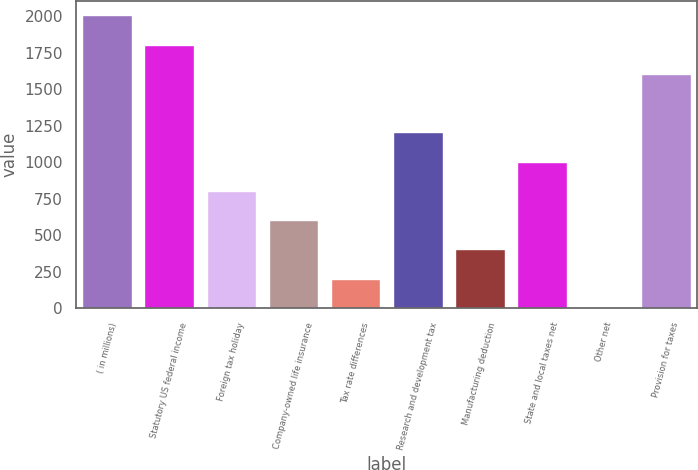<chart> <loc_0><loc_0><loc_500><loc_500><bar_chart><fcel>( in millions)<fcel>Statutory US federal income<fcel>Foreign tax holiday<fcel>Company-owned life insurance<fcel>Tax rate differences<fcel>Research and development tax<fcel>Manufacturing deduction<fcel>State and local taxes net<fcel>Other net<fcel>Provision for taxes<nl><fcel>2006<fcel>1805.49<fcel>802.94<fcel>602.43<fcel>201.41<fcel>1203.96<fcel>401.92<fcel>1003.45<fcel>0.9<fcel>1604.98<nl></chart> 